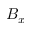Convert formula to latex. <formula><loc_0><loc_0><loc_500><loc_500>B _ { x }</formula> 